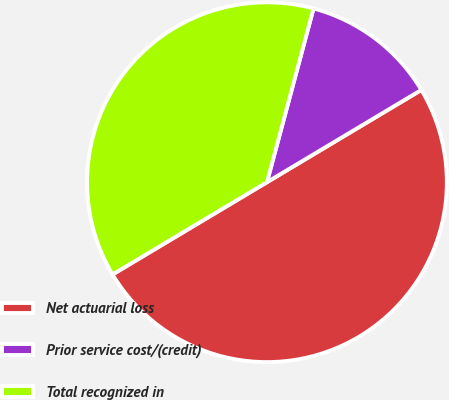<chart> <loc_0><loc_0><loc_500><loc_500><pie_chart><fcel>Net actuarial loss<fcel>Prior service cost/(credit)<fcel>Total recognized in<nl><fcel>50.0%<fcel>12.26%<fcel>37.74%<nl></chart> 